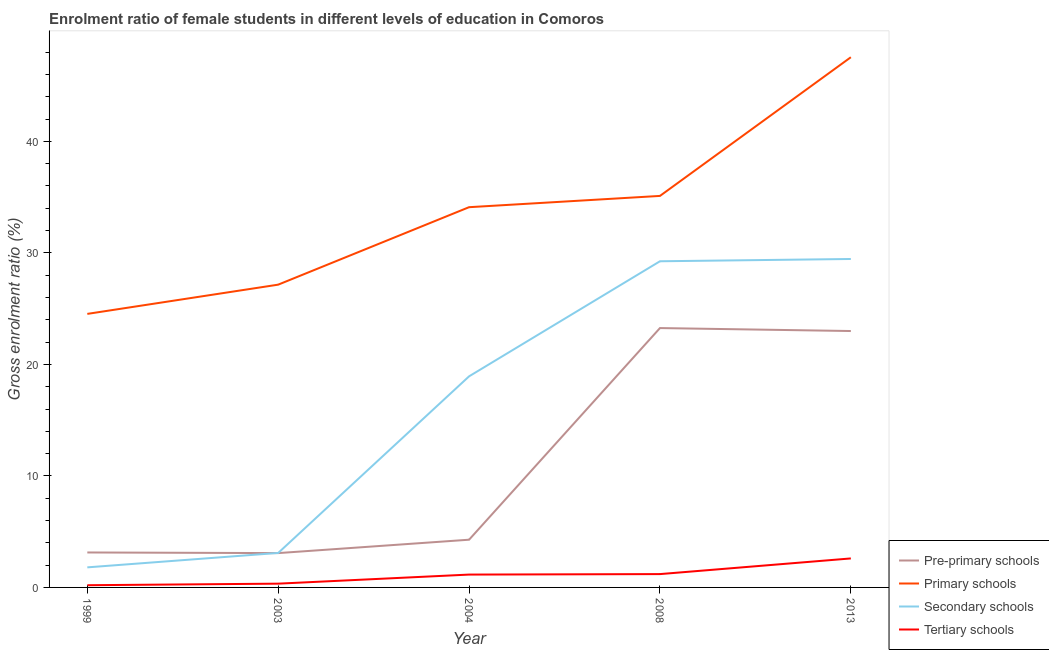How many different coloured lines are there?
Your answer should be very brief. 4. What is the gross enrolment ratio(male) in primary schools in 1999?
Your answer should be very brief. 24.53. Across all years, what is the maximum gross enrolment ratio(male) in secondary schools?
Offer a very short reply. 29.45. Across all years, what is the minimum gross enrolment ratio(male) in primary schools?
Give a very brief answer. 24.53. In which year was the gross enrolment ratio(male) in secondary schools minimum?
Your response must be concise. 1999. What is the total gross enrolment ratio(male) in primary schools in the graph?
Ensure brevity in your answer.  168.44. What is the difference between the gross enrolment ratio(male) in pre-primary schools in 2003 and that in 2008?
Provide a succinct answer. -20.18. What is the difference between the gross enrolment ratio(male) in pre-primary schools in 2003 and the gross enrolment ratio(male) in tertiary schools in 2013?
Offer a very short reply. 0.48. What is the average gross enrolment ratio(male) in pre-primary schools per year?
Offer a terse response. 11.35. In the year 2003, what is the difference between the gross enrolment ratio(male) in primary schools and gross enrolment ratio(male) in tertiary schools?
Provide a short and direct response. 26.81. What is the ratio of the gross enrolment ratio(male) in pre-primary schools in 1999 to that in 2013?
Provide a succinct answer. 0.14. Is the gross enrolment ratio(male) in primary schools in 2008 less than that in 2013?
Provide a short and direct response. Yes. Is the difference between the gross enrolment ratio(male) in tertiary schools in 2008 and 2013 greater than the difference between the gross enrolment ratio(male) in secondary schools in 2008 and 2013?
Keep it short and to the point. No. What is the difference between the highest and the second highest gross enrolment ratio(male) in tertiary schools?
Offer a very short reply. 1.4. What is the difference between the highest and the lowest gross enrolment ratio(male) in tertiary schools?
Your response must be concise. 2.4. Is the sum of the gross enrolment ratio(male) in primary schools in 2003 and 2004 greater than the maximum gross enrolment ratio(male) in pre-primary schools across all years?
Ensure brevity in your answer.  Yes. Is it the case that in every year, the sum of the gross enrolment ratio(male) in pre-primary schools and gross enrolment ratio(male) in primary schools is greater than the sum of gross enrolment ratio(male) in secondary schools and gross enrolment ratio(male) in tertiary schools?
Provide a short and direct response. No. Does the gross enrolment ratio(male) in pre-primary schools monotonically increase over the years?
Your response must be concise. No. Is the gross enrolment ratio(male) in primary schools strictly less than the gross enrolment ratio(male) in tertiary schools over the years?
Make the answer very short. No. How many lines are there?
Offer a terse response. 4. How many years are there in the graph?
Your answer should be very brief. 5. What is the title of the graph?
Ensure brevity in your answer.  Enrolment ratio of female students in different levels of education in Comoros. Does "Industry" appear as one of the legend labels in the graph?
Your answer should be very brief. No. What is the label or title of the X-axis?
Provide a short and direct response. Year. What is the Gross enrolment ratio (%) in Pre-primary schools in 1999?
Keep it short and to the point. 3.13. What is the Gross enrolment ratio (%) in Primary schools in 1999?
Give a very brief answer. 24.53. What is the Gross enrolment ratio (%) in Secondary schools in 1999?
Provide a succinct answer. 1.8. What is the Gross enrolment ratio (%) of Tertiary schools in 1999?
Your response must be concise. 0.2. What is the Gross enrolment ratio (%) of Pre-primary schools in 2003?
Offer a terse response. 3.08. What is the Gross enrolment ratio (%) of Primary schools in 2003?
Your response must be concise. 27.15. What is the Gross enrolment ratio (%) in Secondary schools in 2003?
Ensure brevity in your answer.  3.09. What is the Gross enrolment ratio (%) in Tertiary schools in 2003?
Your response must be concise. 0.34. What is the Gross enrolment ratio (%) in Pre-primary schools in 2004?
Make the answer very short. 4.28. What is the Gross enrolment ratio (%) of Primary schools in 2004?
Ensure brevity in your answer.  34.1. What is the Gross enrolment ratio (%) of Secondary schools in 2004?
Your response must be concise. 18.93. What is the Gross enrolment ratio (%) in Tertiary schools in 2004?
Your answer should be compact. 1.15. What is the Gross enrolment ratio (%) of Pre-primary schools in 2008?
Make the answer very short. 23.26. What is the Gross enrolment ratio (%) of Primary schools in 2008?
Make the answer very short. 35.11. What is the Gross enrolment ratio (%) of Secondary schools in 2008?
Offer a very short reply. 29.25. What is the Gross enrolment ratio (%) of Tertiary schools in 2008?
Ensure brevity in your answer.  1.2. What is the Gross enrolment ratio (%) in Pre-primary schools in 2013?
Your answer should be very brief. 22.99. What is the Gross enrolment ratio (%) of Primary schools in 2013?
Your answer should be compact. 47.55. What is the Gross enrolment ratio (%) in Secondary schools in 2013?
Ensure brevity in your answer.  29.45. What is the Gross enrolment ratio (%) in Tertiary schools in 2013?
Your response must be concise. 2.6. Across all years, what is the maximum Gross enrolment ratio (%) in Pre-primary schools?
Give a very brief answer. 23.26. Across all years, what is the maximum Gross enrolment ratio (%) of Primary schools?
Ensure brevity in your answer.  47.55. Across all years, what is the maximum Gross enrolment ratio (%) in Secondary schools?
Keep it short and to the point. 29.45. Across all years, what is the maximum Gross enrolment ratio (%) of Tertiary schools?
Ensure brevity in your answer.  2.6. Across all years, what is the minimum Gross enrolment ratio (%) in Pre-primary schools?
Provide a succinct answer. 3.08. Across all years, what is the minimum Gross enrolment ratio (%) in Primary schools?
Offer a terse response. 24.53. Across all years, what is the minimum Gross enrolment ratio (%) in Secondary schools?
Your response must be concise. 1.8. Across all years, what is the minimum Gross enrolment ratio (%) of Tertiary schools?
Offer a very short reply. 0.2. What is the total Gross enrolment ratio (%) of Pre-primary schools in the graph?
Keep it short and to the point. 56.75. What is the total Gross enrolment ratio (%) in Primary schools in the graph?
Keep it short and to the point. 168.44. What is the total Gross enrolment ratio (%) in Secondary schools in the graph?
Your answer should be compact. 82.53. What is the total Gross enrolment ratio (%) of Tertiary schools in the graph?
Your response must be concise. 5.48. What is the difference between the Gross enrolment ratio (%) of Pre-primary schools in 1999 and that in 2003?
Ensure brevity in your answer.  0.06. What is the difference between the Gross enrolment ratio (%) in Primary schools in 1999 and that in 2003?
Make the answer very short. -2.62. What is the difference between the Gross enrolment ratio (%) in Secondary schools in 1999 and that in 2003?
Provide a short and direct response. -1.29. What is the difference between the Gross enrolment ratio (%) in Tertiary schools in 1999 and that in 2003?
Your answer should be compact. -0.14. What is the difference between the Gross enrolment ratio (%) of Pre-primary schools in 1999 and that in 2004?
Provide a short and direct response. -1.15. What is the difference between the Gross enrolment ratio (%) of Primary schools in 1999 and that in 2004?
Offer a terse response. -9.57. What is the difference between the Gross enrolment ratio (%) of Secondary schools in 1999 and that in 2004?
Provide a short and direct response. -17.13. What is the difference between the Gross enrolment ratio (%) of Tertiary schools in 1999 and that in 2004?
Ensure brevity in your answer.  -0.95. What is the difference between the Gross enrolment ratio (%) of Pre-primary schools in 1999 and that in 2008?
Offer a terse response. -20.12. What is the difference between the Gross enrolment ratio (%) in Primary schools in 1999 and that in 2008?
Provide a short and direct response. -10.58. What is the difference between the Gross enrolment ratio (%) in Secondary schools in 1999 and that in 2008?
Provide a short and direct response. -27.45. What is the difference between the Gross enrolment ratio (%) of Tertiary schools in 1999 and that in 2008?
Provide a short and direct response. -1. What is the difference between the Gross enrolment ratio (%) in Pre-primary schools in 1999 and that in 2013?
Your answer should be very brief. -19.86. What is the difference between the Gross enrolment ratio (%) of Primary schools in 1999 and that in 2013?
Make the answer very short. -23.02. What is the difference between the Gross enrolment ratio (%) of Secondary schools in 1999 and that in 2013?
Provide a succinct answer. -27.66. What is the difference between the Gross enrolment ratio (%) in Tertiary schools in 1999 and that in 2013?
Give a very brief answer. -2.4. What is the difference between the Gross enrolment ratio (%) in Pre-primary schools in 2003 and that in 2004?
Your answer should be compact. -1.2. What is the difference between the Gross enrolment ratio (%) in Primary schools in 2003 and that in 2004?
Make the answer very short. -6.95. What is the difference between the Gross enrolment ratio (%) in Secondary schools in 2003 and that in 2004?
Provide a short and direct response. -15.84. What is the difference between the Gross enrolment ratio (%) in Tertiary schools in 2003 and that in 2004?
Your answer should be very brief. -0.81. What is the difference between the Gross enrolment ratio (%) in Pre-primary schools in 2003 and that in 2008?
Keep it short and to the point. -20.18. What is the difference between the Gross enrolment ratio (%) in Primary schools in 2003 and that in 2008?
Your answer should be very brief. -7.96. What is the difference between the Gross enrolment ratio (%) in Secondary schools in 2003 and that in 2008?
Ensure brevity in your answer.  -26.16. What is the difference between the Gross enrolment ratio (%) in Tertiary schools in 2003 and that in 2008?
Offer a very short reply. -0.86. What is the difference between the Gross enrolment ratio (%) of Pre-primary schools in 2003 and that in 2013?
Keep it short and to the point. -19.91. What is the difference between the Gross enrolment ratio (%) of Primary schools in 2003 and that in 2013?
Offer a terse response. -20.4. What is the difference between the Gross enrolment ratio (%) in Secondary schools in 2003 and that in 2013?
Offer a very short reply. -26.36. What is the difference between the Gross enrolment ratio (%) of Tertiary schools in 2003 and that in 2013?
Offer a very short reply. -2.26. What is the difference between the Gross enrolment ratio (%) of Pre-primary schools in 2004 and that in 2008?
Your answer should be compact. -18.98. What is the difference between the Gross enrolment ratio (%) in Primary schools in 2004 and that in 2008?
Your response must be concise. -1.01. What is the difference between the Gross enrolment ratio (%) in Secondary schools in 2004 and that in 2008?
Offer a terse response. -10.32. What is the difference between the Gross enrolment ratio (%) of Tertiary schools in 2004 and that in 2008?
Provide a short and direct response. -0.04. What is the difference between the Gross enrolment ratio (%) of Pre-primary schools in 2004 and that in 2013?
Your response must be concise. -18.71. What is the difference between the Gross enrolment ratio (%) of Primary schools in 2004 and that in 2013?
Make the answer very short. -13.45. What is the difference between the Gross enrolment ratio (%) in Secondary schools in 2004 and that in 2013?
Provide a short and direct response. -10.52. What is the difference between the Gross enrolment ratio (%) in Tertiary schools in 2004 and that in 2013?
Your answer should be very brief. -1.45. What is the difference between the Gross enrolment ratio (%) of Pre-primary schools in 2008 and that in 2013?
Provide a succinct answer. 0.27. What is the difference between the Gross enrolment ratio (%) in Primary schools in 2008 and that in 2013?
Give a very brief answer. -12.44. What is the difference between the Gross enrolment ratio (%) of Secondary schools in 2008 and that in 2013?
Make the answer very short. -0.2. What is the difference between the Gross enrolment ratio (%) of Tertiary schools in 2008 and that in 2013?
Your response must be concise. -1.4. What is the difference between the Gross enrolment ratio (%) of Pre-primary schools in 1999 and the Gross enrolment ratio (%) of Primary schools in 2003?
Keep it short and to the point. -24.02. What is the difference between the Gross enrolment ratio (%) of Pre-primary schools in 1999 and the Gross enrolment ratio (%) of Secondary schools in 2003?
Keep it short and to the point. 0.04. What is the difference between the Gross enrolment ratio (%) in Pre-primary schools in 1999 and the Gross enrolment ratio (%) in Tertiary schools in 2003?
Provide a short and direct response. 2.8. What is the difference between the Gross enrolment ratio (%) in Primary schools in 1999 and the Gross enrolment ratio (%) in Secondary schools in 2003?
Offer a very short reply. 21.44. What is the difference between the Gross enrolment ratio (%) in Primary schools in 1999 and the Gross enrolment ratio (%) in Tertiary schools in 2003?
Provide a succinct answer. 24.19. What is the difference between the Gross enrolment ratio (%) in Secondary schools in 1999 and the Gross enrolment ratio (%) in Tertiary schools in 2003?
Your answer should be compact. 1.46. What is the difference between the Gross enrolment ratio (%) in Pre-primary schools in 1999 and the Gross enrolment ratio (%) in Primary schools in 2004?
Provide a succinct answer. -30.97. What is the difference between the Gross enrolment ratio (%) of Pre-primary schools in 1999 and the Gross enrolment ratio (%) of Secondary schools in 2004?
Give a very brief answer. -15.8. What is the difference between the Gross enrolment ratio (%) of Pre-primary schools in 1999 and the Gross enrolment ratio (%) of Tertiary schools in 2004?
Your answer should be compact. 1.98. What is the difference between the Gross enrolment ratio (%) in Primary schools in 1999 and the Gross enrolment ratio (%) in Secondary schools in 2004?
Offer a terse response. 5.6. What is the difference between the Gross enrolment ratio (%) of Primary schools in 1999 and the Gross enrolment ratio (%) of Tertiary schools in 2004?
Keep it short and to the point. 23.38. What is the difference between the Gross enrolment ratio (%) in Secondary schools in 1999 and the Gross enrolment ratio (%) in Tertiary schools in 2004?
Give a very brief answer. 0.65. What is the difference between the Gross enrolment ratio (%) of Pre-primary schools in 1999 and the Gross enrolment ratio (%) of Primary schools in 2008?
Your response must be concise. -31.98. What is the difference between the Gross enrolment ratio (%) in Pre-primary schools in 1999 and the Gross enrolment ratio (%) in Secondary schools in 2008?
Offer a very short reply. -26.12. What is the difference between the Gross enrolment ratio (%) of Pre-primary schools in 1999 and the Gross enrolment ratio (%) of Tertiary schools in 2008?
Your answer should be compact. 1.94. What is the difference between the Gross enrolment ratio (%) of Primary schools in 1999 and the Gross enrolment ratio (%) of Secondary schools in 2008?
Keep it short and to the point. -4.72. What is the difference between the Gross enrolment ratio (%) in Primary schools in 1999 and the Gross enrolment ratio (%) in Tertiary schools in 2008?
Make the answer very short. 23.33. What is the difference between the Gross enrolment ratio (%) of Secondary schools in 1999 and the Gross enrolment ratio (%) of Tertiary schools in 2008?
Ensure brevity in your answer.  0.6. What is the difference between the Gross enrolment ratio (%) in Pre-primary schools in 1999 and the Gross enrolment ratio (%) in Primary schools in 2013?
Your response must be concise. -44.41. What is the difference between the Gross enrolment ratio (%) in Pre-primary schools in 1999 and the Gross enrolment ratio (%) in Secondary schools in 2013?
Offer a very short reply. -26.32. What is the difference between the Gross enrolment ratio (%) in Pre-primary schools in 1999 and the Gross enrolment ratio (%) in Tertiary schools in 2013?
Your response must be concise. 0.53. What is the difference between the Gross enrolment ratio (%) of Primary schools in 1999 and the Gross enrolment ratio (%) of Secondary schools in 2013?
Ensure brevity in your answer.  -4.92. What is the difference between the Gross enrolment ratio (%) of Primary schools in 1999 and the Gross enrolment ratio (%) of Tertiary schools in 2013?
Keep it short and to the point. 21.93. What is the difference between the Gross enrolment ratio (%) in Secondary schools in 1999 and the Gross enrolment ratio (%) in Tertiary schools in 2013?
Provide a succinct answer. -0.8. What is the difference between the Gross enrolment ratio (%) in Pre-primary schools in 2003 and the Gross enrolment ratio (%) in Primary schools in 2004?
Provide a short and direct response. -31.02. What is the difference between the Gross enrolment ratio (%) of Pre-primary schools in 2003 and the Gross enrolment ratio (%) of Secondary schools in 2004?
Give a very brief answer. -15.85. What is the difference between the Gross enrolment ratio (%) of Pre-primary schools in 2003 and the Gross enrolment ratio (%) of Tertiary schools in 2004?
Make the answer very short. 1.93. What is the difference between the Gross enrolment ratio (%) in Primary schools in 2003 and the Gross enrolment ratio (%) in Secondary schools in 2004?
Ensure brevity in your answer.  8.22. What is the difference between the Gross enrolment ratio (%) in Primary schools in 2003 and the Gross enrolment ratio (%) in Tertiary schools in 2004?
Offer a terse response. 26. What is the difference between the Gross enrolment ratio (%) in Secondary schools in 2003 and the Gross enrolment ratio (%) in Tertiary schools in 2004?
Keep it short and to the point. 1.94. What is the difference between the Gross enrolment ratio (%) of Pre-primary schools in 2003 and the Gross enrolment ratio (%) of Primary schools in 2008?
Your response must be concise. -32.03. What is the difference between the Gross enrolment ratio (%) of Pre-primary schools in 2003 and the Gross enrolment ratio (%) of Secondary schools in 2008?
Provide a short and direct response. -26.17. What is the difference between the Gross enrolment ratio (%) in Pre-primary schools in 2003 and the Gross enrolment ratio (%) in Tertiary schools in 2008?
Your answer should be very brief. 1.88. What is the difference between the Gross enrolment ratio (%) of Primary schools in 2003 and the Gross enrolment ratio (%) of Secondary schools in 2008?
Keep it short and to the point. -2.1. What is the difference between the Gross enrolment ratio (%) of Primary schools in 2003 and the Gross enrolment ratio (%) of Tertiary schools in 2008?
Your answer should be very brief. 25.96. What is the difference between the Gross enrolment ratio (%) in Secondary schools in 2003 and the Gross enrolment ratio (%) in Tertiary schools in 2008?
Give a very brief answer. 1.9. What is the difference between the Gross enrolment ratio (%) in Pre-primary schools in 2003 and the Gross enrolment ratio (%) in Primary schools in 2013?
Provide a short and direct response. -44.47. What is the difference between the Gross enrolment ratio (%) in Pre-primary schools in 2003 and the Gross enrolment ratio (%) in Secondary schools in 2013?
Offer a terse response. -26.38. What is the difference between the Gross enrolment ratio (%) in Pre-primary schools in 2003 and the Gross enrolment ratio (%) in Tertiary schools in 2013?
Your answer should be very brief. 0.48. What is the difference between the Gross enrolment ratio (%) in Primary schools in 2003 and the Gross enrolment ratio (%) in Secondary schools in 2013?
Your answer should be very brief. -2.3. What is the difference between the Gross enrolment ratio (%) in Primary schools in 2003 and the Gross enrolment ratio (%) in Tertiary schools in 2013?
Give a very brief answer. 24.55. What is the difference between the Gross enrolment ratio (%) in Secondary schools in 2003 and the Gross enrolment ratio (%) in Tertiary schools in 2013?
Offer a very short reply. 0.49. What is the difference between the Gross enrolment ratio (%) of Pre-primary schools in 2004 and the Gross enrolment ratio (%) of Primary schools in 2008?
Give a very brief answer. -30.83. What is the difference between the Gross enrolment ratio (%) in Pre-primary schools in 2004 and the Gross enrolment ratio (%) in Secondary schools in 2008?
Ensure brevity in your answer.  -24.97. What is the difference between the Gross enrolment ratio (%) of Pre-primary schools in 2004 and the Gross enrolment ratio (%) of Tertiary schools in 2008?
Provide a succinct answer. 3.08. What is the difference between the Gross enrolment ratio (%) of Primary schools in 2004 and the Gross enrolment ratio (%) of Secondary schools in 2008?
Your response must be concise. 4.85. What is the difference between the Gross enrolment ratio (%) in Primary schools in 2004 and the Gross enrolment ratio (%) in Tertiary schools in 2008?
Offer a very short reply. 32.9. What is the difference between the Gross enrolment ratio (%) in Secondary schools in 2004 and the Gross enrolment ratio (%) in Tertiary schools in 2008?
Provide a short and direct response. 17.73. What is the difference between the Gross enrolment ratio (%) of Pre-primary schools in 2004 and the Gross enrolment ratio (%) of Primary schools in 2013?
Make the answer very short. -43.27. What is the difference between the Gross enrolment ratio (%) of Pre-primary schools in 2004 and the Gross enrolment ratio (%) of Secondary schools in 2013?
Your answer should be very brief. -25.17. What is the difference between the Gross enrolment ratio (%) in Pre-primary schools in 2004 and the Gross enrolment ratio (%) in Tertiary schools in 2013?
Offer a very short reply. 1.68. What is the difference between the Gross enrolment ratio (%) in Primary schools in 2004 and the Gross enrolment ratio (%) in Secondary schools in 2013?
Ensure brevity in your answer.  4.64. What is the difference between the Gross enrolment ratio (%) of Primary schools in 2004 and the Gross enrolment ratio (%) of Tertiary schools in 2013?
Offer a very short reply. 31.5. What is the difference between the Gross enrolment ratio (%) in Secondary schools in 2004 and the Gross enrolment ratio (%) in Tertiary schools in 2013?
Offer a very short reply. 16.33. What is the difference between the Gross enrolment ratio (%) of Pre-primary schools in 2008 and the Gross enrolment ratio (%) of Primary schools in 2013?
Ensure brevity in your answer.  -24.29. What is the difference between the Gross enrolment ratio (%) of Pre-primary schools in 2008 and the Gross enrolment ratio (%) of Secondary schools in 2013?
Offer a terse response. -6.2. What is the difference between the Gross enrolment ratio (%) of Pre-primary schools in 2008 and the Gross enrolment ratio (%) of Tertiary schools in 2013?
Provide a short and direct response. 20.66. What is the difference between the Gross enrolment ratio (%) of Primary schools in 2008 and the Gross enrolment ratio (%) of Secondary schools in 2013?
Provide a short and direct response. 5.66. What is the difference between the Gross enrolment ratio (%) in Primary schools in 2008 and the Gross enrolment ratio (%) in Tertiary schools in 2013?
Ensure brevity in your answer.  32.51. What is the difference between the Gross enrolment ratio (%) in Secondary schools in 2008 and the Gross enrolment ratio (%) in Tertiary schools in 2013?
Make the answer very short. 26.65. What is the average Gross enrolment ratio (%) of Pre-primary schools per year?
Offer a very short reply. 11.35. What is the average Gross enrolment ratio (%) of Primary schools per year?
Your response must be concise. 33.69. What is the average Gross enrolment ratio (%) of Secondary schools per year?
Offer a terse response. 16.51. What is the average Gross enrolment ratio (%) in Tertiary schools per year?
Your response must be concise. 1.1. In the year 1999, what is the difference between the Gross enrolment ratio (%) in Pre-primary schools and Gross enrolment ratio (%) in Primary schools?
Provide a succinct answer. -21.4. In the year 1999, what is the difference between the Gross enrolment ratio (%) in Pre-primary schools and Gross enrolment ratio (%) in Secondary schools?
Keep it short and to the point. 1.34. In the year 1999, what is the difference between the Gross enrolment ratio (%) in Pre-primary schools and Gross enrolment ratio (%) in Tertiary schools?
Offer a very short reply. 2.94. In the year 1999, what is the difference between the Gross enrolment ratio (%) in Primary schools and Gross enrolment ratio (%) in Secondary schools?
Ensure brevity in your answer.  22.73. In the year 1999, what is the difference between the Gross enrolment ratio (%) of Primary schools and Gross enrolment ratio (%) of Tertiary schools?
Offer a very short reply. 24.33. In the year 1999, what is the difference between the Gross enrolment ratio (%) of Secondary schools and Gross enrolment ratio (%) of Tertiary schools?
Ensure brevity in your answer.  1.6. In the year 2003, what is the difference between the Gross enrolment ratio (%) of Pre-primary schools and Gross enrolment ratio (%) of Primary schools?
Give a very brief answer. -24.07. In the year 2003, what is the difference between the Gross enrolment ratio (%) of Pre-primary schools and Gross enrolment ratio (%) of Secondary schools?
Give a very brief answer. -0.01. In the year 2003, what is the difference between the Gross enrolment ratio (%) in Pre-primary schools and Gross enrolment ratio (%) in Tertiary schools?
Ensure brevity in your answer.  2.74. In the year 2003, what is the difference between the Gross enrolment ratio (%) in Primary schools and Gross enrolment ratio (%) in Secondary schools?
Your answer should be compact. 24.06. In the year 2003, what is the difference between the Gross enrolment ratio (%) in Primary schools and Gross enrolment ratio (%) in Tertiary schools?
Provide a succinct answer. 26.81. In the year 2003, what is the difference between the Gross enrolment ratio (%) of Secondary schools and Gross enrolment ratio (%) of Tertiary schools?
Make the answer very short. 2.75. In the year 2004, what is the difference between the Gross enrolment ratio (%) in Pre-primary schools and Gross enrolment ratio (%) in Primary schools?
Keep it short and to the point. -29.82. In the year 2004, what is the difference between the Gross enrolment ratio (%) of Pre-primary schools and Gross enrolment ratio (%) of Secondary schools?
Provide a succinct answer. -14.65. In the year 2004, what is the difference between the Gross enrolment ratio (%) in Pre-primary schools and Gross enrolment ratio (%) in Tertiary schools?
Ensure brevity in your answer.  3.13. In the year 2004, what is the difference between the Gross enrolment ratio (%) in Primary schools and Gross enrolment ratio (%) in Secondary schools?
Your answer should be compact. 15.17. In the year 2004, what is the difference between the Gross enrolment ratio (%) of Primary schools and Gross enrolment ratio (%) of Tertiary schools?
Your answer should be compact. 32.95. In the year 2004, what is the difference between the Gross enrolment ratio (%) of Secondary schools and Gross enrolment ratio (%) of Tertiary schools?
Provide a short and direct response. 17.78. In the year 2008, what is the difference between the Gross enrolment ratio (%) in Pre-primary schools and Gross enrolment ratio (%) in Primary schools?
Keep it short and to the point. -11.85. In the year 2008, what is the difference between the Gross enrolment ratio (%) of Pre-primary schools and Gross enrolment ratio (%) of Secondary schools?
Your answer should be compact. -5.99. In the year 2008, what is the difference between the Gross enrolment ratio (%) of Pre-primary schools and Gross enrolment ratio (%) of Tertiary schools?
Give a very brief answer. 22.06. In the year 2008, what is the difference between the Gross enrolment ratio (%) in Primary schools and Gross enrolment ratio (%) in Secondary schools?
Ensure brevity in your answer.  5.86. In the year 2008, what is the difference between the Gross enrolment ratio (%) in Primary schools and Gross enrolment ratio (%) in Tertiary schools?
Your answer should be compact. 33.91. In the year 2008, what is the difference between the Gross enrolment ratio (%) of Secondary schools and Gross enrolment ratio (%) of Tertiary schools?
Your answer should be very brief. 28.05. In the year 2013, what is the difference between the Gross enrolment ratio (%) of Pre-primary schools and Gross enrolment ratio (%) of Primary schools?
Make the answer very short. -24.55. In the year 2013, what is the difference between the Gross enrolment ratio (%) of Pre-primary schools and Gross enrolment ratio (%) of Secondary schools?
Give a very brief answer. -6.46. In the year 2013, what is the difference between the Gross enrolment ratio (%) in Pre-primary schools and Gross enrolment ratio (%) in Tertiary schools?
Make the answer very short. 20.39. In the year 2013, what is the difference between the Gross enrolment ratio (%) of Primary schools and Gross enrolment ratio (%) of Secondary schools?
Your response must be concise. 18.09. In the year 2013, what is the difference between the Gross enrolment ratio (%) of Primary schools and Gross enrolment ratio (%) of Tertiary schools?
Keep it short and to the point. 44.95. In the year 2013, what is the difference between the Gross enrolment ratio (%) in Secondary schools and Gross enrolment ratio (%) in Tertiary schools?
Give a very brief answer. 26.85. What is the ratio of the Gross enrolment ratio (%) in Pre-primary schools in 1999 to that in 2003?
Offer a very short reply. 1.02. What is the ratio of the Gross enrolment ratio (%) in Primary schools in 1999 to that in 2003?
Ensure brevity in your answer.  0.9. What is the ratio of the Gross enrolment ratio (%) of Secondary schools in 1999 to that in 2003?
Give a very brief answer. 0.58. What is the ratio of the Gross enrolment ratio (%) in Tertiary schools in 1999 to that in 2003?
Offer a terse response. 0.58. What is the ratio of the Gross enrolment ratio (%) of Pre-primary schools in 1999 to that in 2004?
Make the answer very short. 0.73. What is the ratio of the Gross enrolment ratio (%) of Primary schools in 1999 to that in 2004?
Provide a succinct answer. 0.72. What is the ratio of the Gross enrolment ratio (%) in Secondary schools in 1999 to that in 2004?
Provide a short and direct response. 0.1. What is the ratio of the Gross enrolment ratio (%) in Tertiary schools in 1999 to that in 2004?
Keep it short and to the point. 0.17. What is the ratio of the Gross enrolment ratio (%) of Pre-primary schools in 1999 to that in 2008?
Your answer should be compact. 0.13. What is the ratio of the Gross enrolment ratio (%) in Primary schools in 1999 to that in 2008?
Give a very brief answer. 0.7. What is the ratio of the Gross enrolment ratio (%) in Secondary schools in 1999 to that in 2008?
Keep it short and to the point. 0.06. What is the ratio of the Gross enrolment ratio (%) of Tertiary schools in 1999 to that in 2008?
Make the answer very short. 0.17. What is the ratio of the Gross enrolment ratio (%) in Pre-primary schools in 1999 to that in 2013?
Your answer should be very brief. 0.14. What is the ratio of the Gross enrolment ratio (%) of Primary schools in 1999 to that in 2013?
Offer a very short reply. 0.52. What is the ratio of the Gross enrolment ratio (%) of Secondary schools in 1999 to that in 2013?
Make the answer very short. 0.06. What is the ratio of the Gross enrolment ratio (%) in Tertiary schools in 1999 to that in 2013?
Ensure brevity in your answer.  0.08. What is the ratio of the Gross enrolment ratio (%) of Pre-primary schools in 2003 to that in 2004?
Your answer should be very brief. 0.72. What is the ratio of the Gross enrolment ratio (%) in Primary schools in 2003 to that in 2004?
Your answer should be very brief. 0.8. What is the ratio of the Gross enrolment ratio (%) of Secondary schools in 2003 to that in 2004?
Offer a terse response. 0.16. What is the ratio of the Gross enrolment ratio (%) of Tertiary schools in 2003 to that in 2004?
Offer a terse response. 0.29. What is the ratio of the Gross enrolment ratio (%) in Pre-primary schools in 2003 to that in 2008?
Make the answer very short. 0.13. What is the ratio of the Gross enrolment ratio (%) in Primary schools in 2003 to that in 2008?
Provide a short and direct response. 0.77. What is the ratio of the Gross enrolment ratio (%) in Secondary schools in 2003 to that in 2008?
Your answer should be compact. 0.11. What is the ratio of the Gross enrolment ratio (%) of Tertiary schools in 2003 to that in 2008?
Keep it short and to the point. 0.28. What is the ratio of the Gross enrolment ratio (%) in Pre-primary schools in 2003 to that in 2013?
Offer a terse response. 0.13. What is the ratio of the Gross enrolment ratio (%) in Primary schools in 2003 to that in 2013?
Provide a succinct answer. 0.57. What is the ratio of the Gross enrolment ratio (%) of Secondary schools in 2003 to that in 2013?
Provide a short and direct response. 0.1. What is the ratio of the Gross enrolment ratio (%) in Tertiary schools in 2003 to that in 2013?
Your answer should be very brief. 0.13. What is the ratio of the Gross enrolment ratio (%) in Pre-primary schools in 2004 to that in 2008?
Give a very brief answer. 0.18. What is the ratio of the Gross enrolment ratio (%) of Primary schools in 2004 to that in 2008?
Make the answer very short. 0.97. What is the ratio of the Gross enrolment ratio (%) in Secondary schools in 2004 to that in 2008?
Offer a terse response. 0.65. What is the ratio of the Gross enrolment ratio (%) of Tertiary schools in 2004 to that in 2008?
Offer a terse response. 0.96. What is the ratio of the Gross enrolment ratio (%) of Pre-primary schools in 2004 to that in 2013?
Offer a terse response. 0.19. What is the ratio of the Gross enrolment ratio (%) in Primary schools in 2004 to that in 2013?
Ensure brevity in your answer.  0.72. What is the ratio of the Gross enrolment ratio (%) of Secondary schools in 2004 to that in 2013?
Offer a very short reply. 0.64. What is the ratio of the Gross enrolment ratio (%) in Tertiary schools in 2004 to that in 2013?
Make the answer very short. 0.44. What is the ratio of the Gross enrolment ratio (%) of Pre-primary schools in 2008 to that in 2013?
Your answer should be very brief. 1.01. What is the ratio of the Gross enrolment ratio (%) of Primary schools in 2008 to that in 2013?
Offer a very short reply. 0.74. What is the ratio of the Gross enrolment ratio (%) of Tertiary schools in 2008 to that in 2013?
Offer a very short reply. 0.46. What is the difference between the highest and the second highest Gross enrolment ratio (%) in Pre-primary schools?
Provide a short and direct response. 0.27. What is the difference between the highest and the second highest Gross enrolment ratio (%) of Primary schools?
Ensure brevity in your answer.  12.44. What is the difference between the highest and the second highest Gross enrolment ratio (%) of Secondary schools?
Offer a very short reply. 0.2. What is the difference between the highest and the second highest Gross enrolment ratio (%) in Tertiary schools?
Ensure brevity in your answer.  1.4. What is the difference between the highest and the lowest Gross enrolment ratio (%) of Pre-primary schools?
Offer a terse response. 20.18. What is the difference between the highest and the lowest Gross enrolment ratio (%) in Primary schools?
Ensure brevity in your answer.  23.02. What is the difference between the highest and the lowest Gross enrolment ratio (%) of Secondary schools?
Provide a succinct answer. 27.66. What is the difference between the highest and the lowest Gross enrolment ratio (%) of Tertiary schools?
Provide a succinct answer. 2.4. 